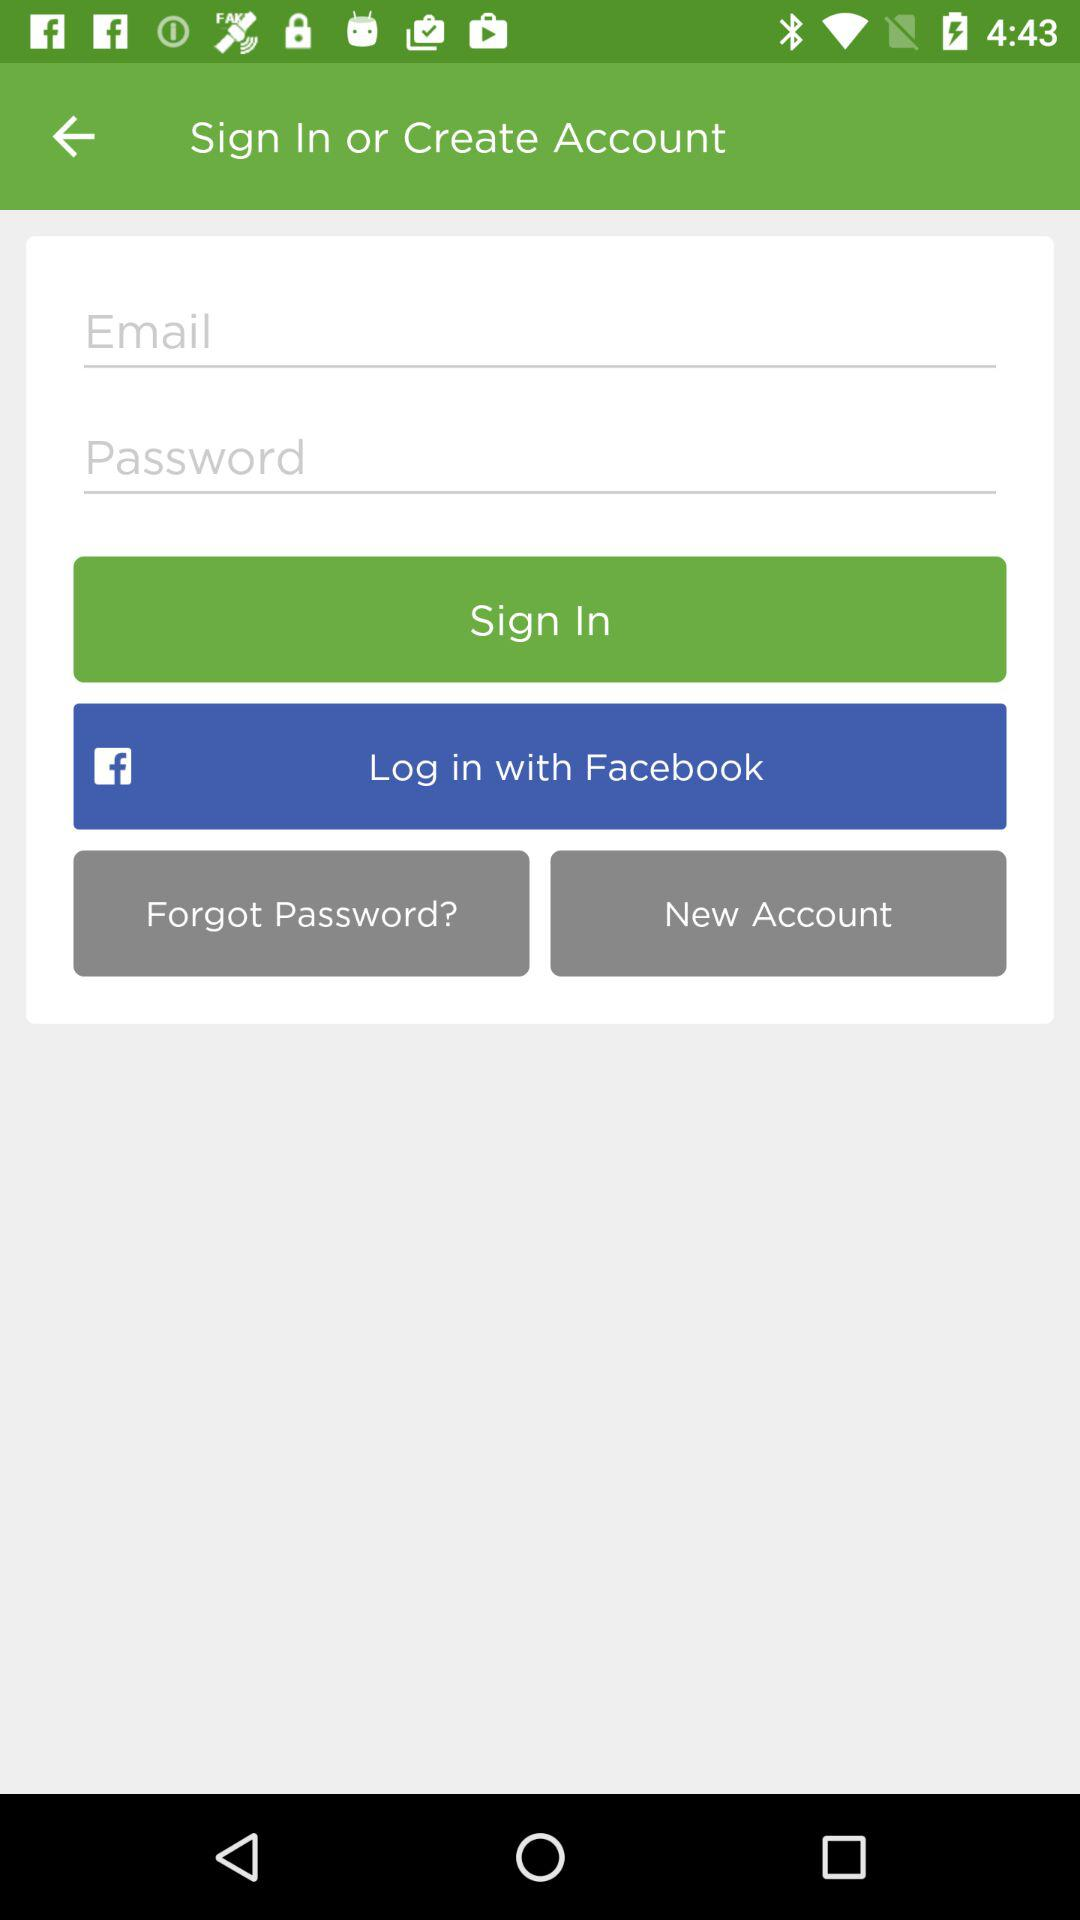What other application can be used to log in to the profile? The application is "Facebook". 